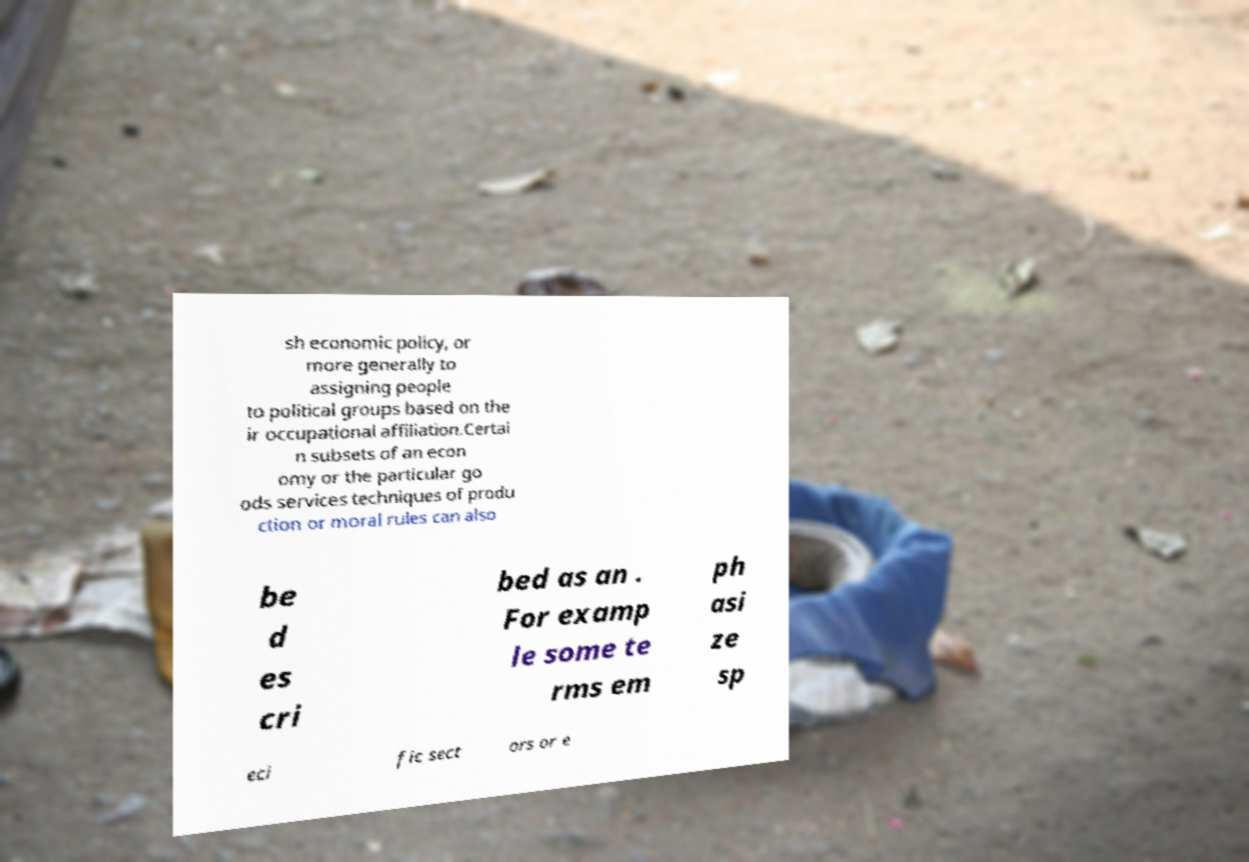Could you extract and type out the text from this image? sh economic policy, or more generally to assigning people to political groups based on the ir occupational affiliation.Certai n subsets of an econ omy or the particular go ods services techniques of produ ction or moral rules can also be d es cri bed as an . For examp le some te rms em ph asi ze sp eci fic sect ors or e 